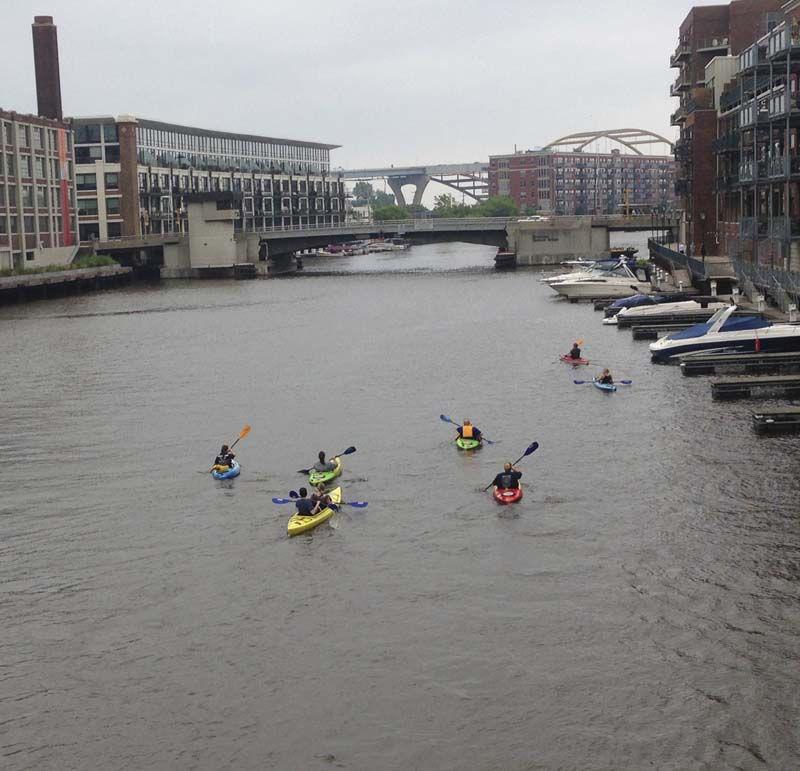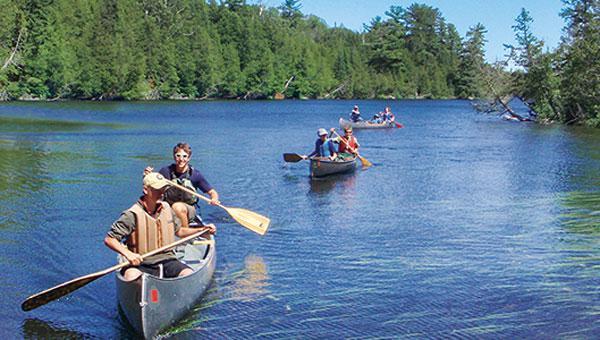The first image is the image on the left, the second image is the image on the right. For the images shown, is this caption "There is exactly one boat in the right image." true? Answer yes or no. No. The first image is the image on the left, the second image is the image on the right. Examine the images to the left and right. Is the description "Multiple canoes are moving in one direction on a canal lined with buildings and with a bridge in the background." accurate? Answer yes or no. Yes. 